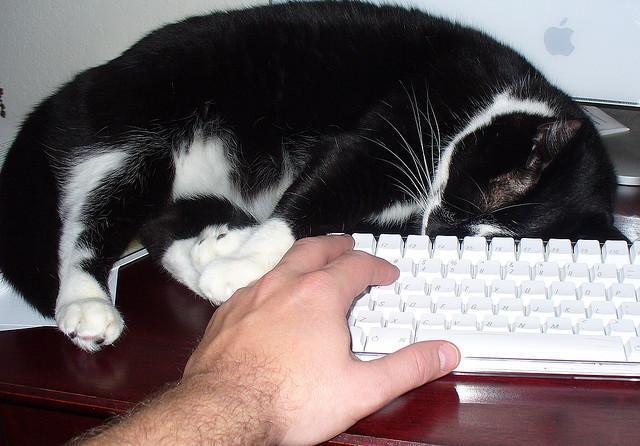How many cats can you see?
Give a very brief answer. 1. How many people can you see?
Give a very brief answer. 1. How many keyboards are in the picture?
Give a very brief answer. 1. 